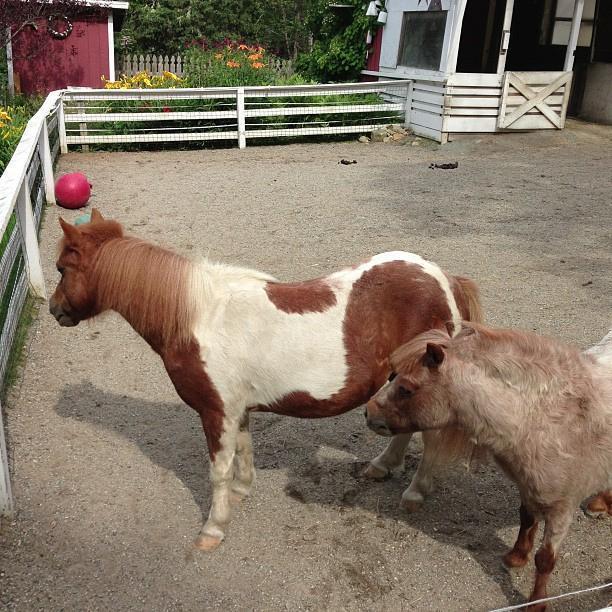How many horses are there?
Give a very brief answer. 2. 